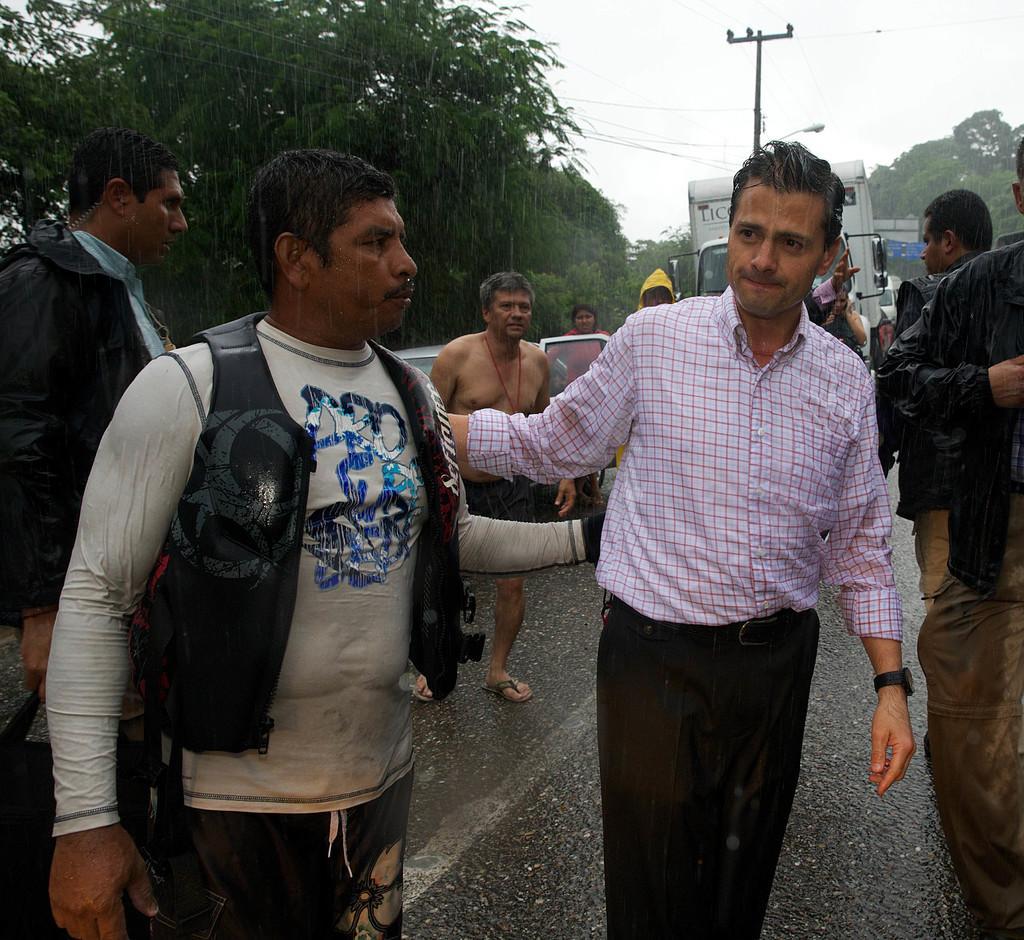Describe this image in one or two sentences. There are people on the road. In the background we can see vehicles, current pole, light, wires, trees and sky. 